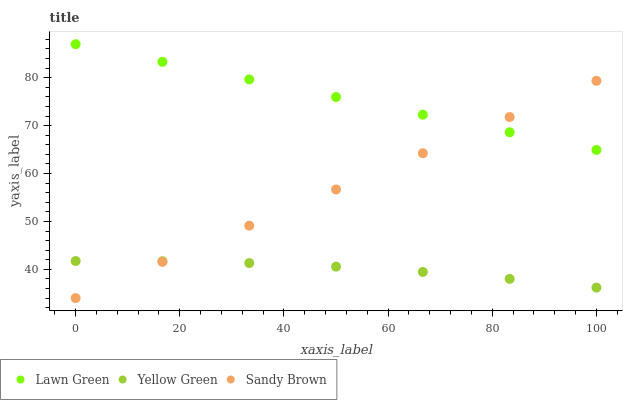Does Yellow Green have the minimum area under the curve?
Answer yes or no. Yes. Does Lawn Green have the maximum area under the curve?
Answer yes or no. Yes. Does Sandy Brown have the minimum area under the curve?
Answer yes or no. No. Does Sandy Brown have the maximum area under the curve?
Answer yes or no. No. Is Sandy Brown the smoothest?
Answer yes or no. Yes. Is Yellow Green the roughest?
Answer yes or no. Yes. Is Yellow Green the smoothest?
Answer yes or no. No. Is Sandy Brown the roughest?
Answer yes or no. No. Does Sandy Brown have the lowest value?
Answer yes or no. Yes. Does Yellow Green have the lowest value?
Answer yes or no. No. Does Lawn Green have the highest value?
Answer yes or no. Yes. Does Sandy Brown have the highest value?
Answer yes or no. No. Is Yellow Green less than Lawn Green?
Answer yes or no. Yes. Is Lawn Green greater than Yellow Green?
Answer yes or no. Yes. Does Sandy Brown intersect Lawn Green?
Answer yes or no. Yes. Is Sandy Brown less than Lawn Green?
Answer yes or no. No. Is Sandy Brown greater than Lawn Green?
Answer yes or no. No. Does Yellow Green intersect Lawn Green?
Answer yes or no. No. 